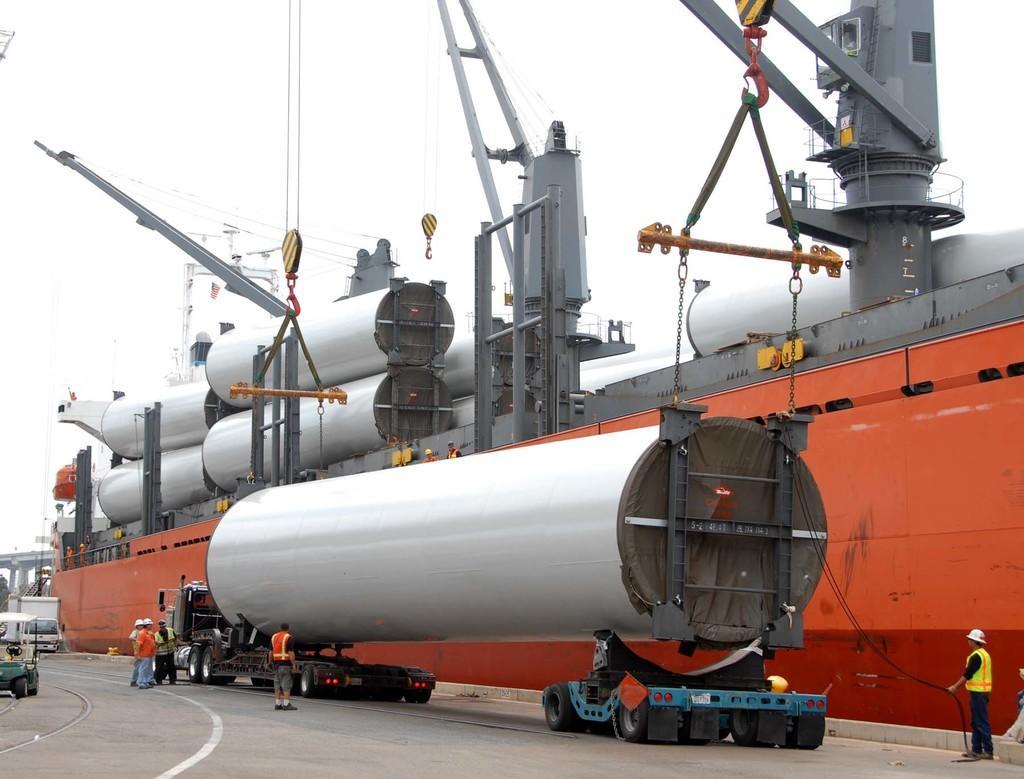Could you give a brief overview of what you see in this image? In this image, we can see people wearing helmets and there are tankers, chains and hangers and some vehicles on the road. At the top, there is sky. 